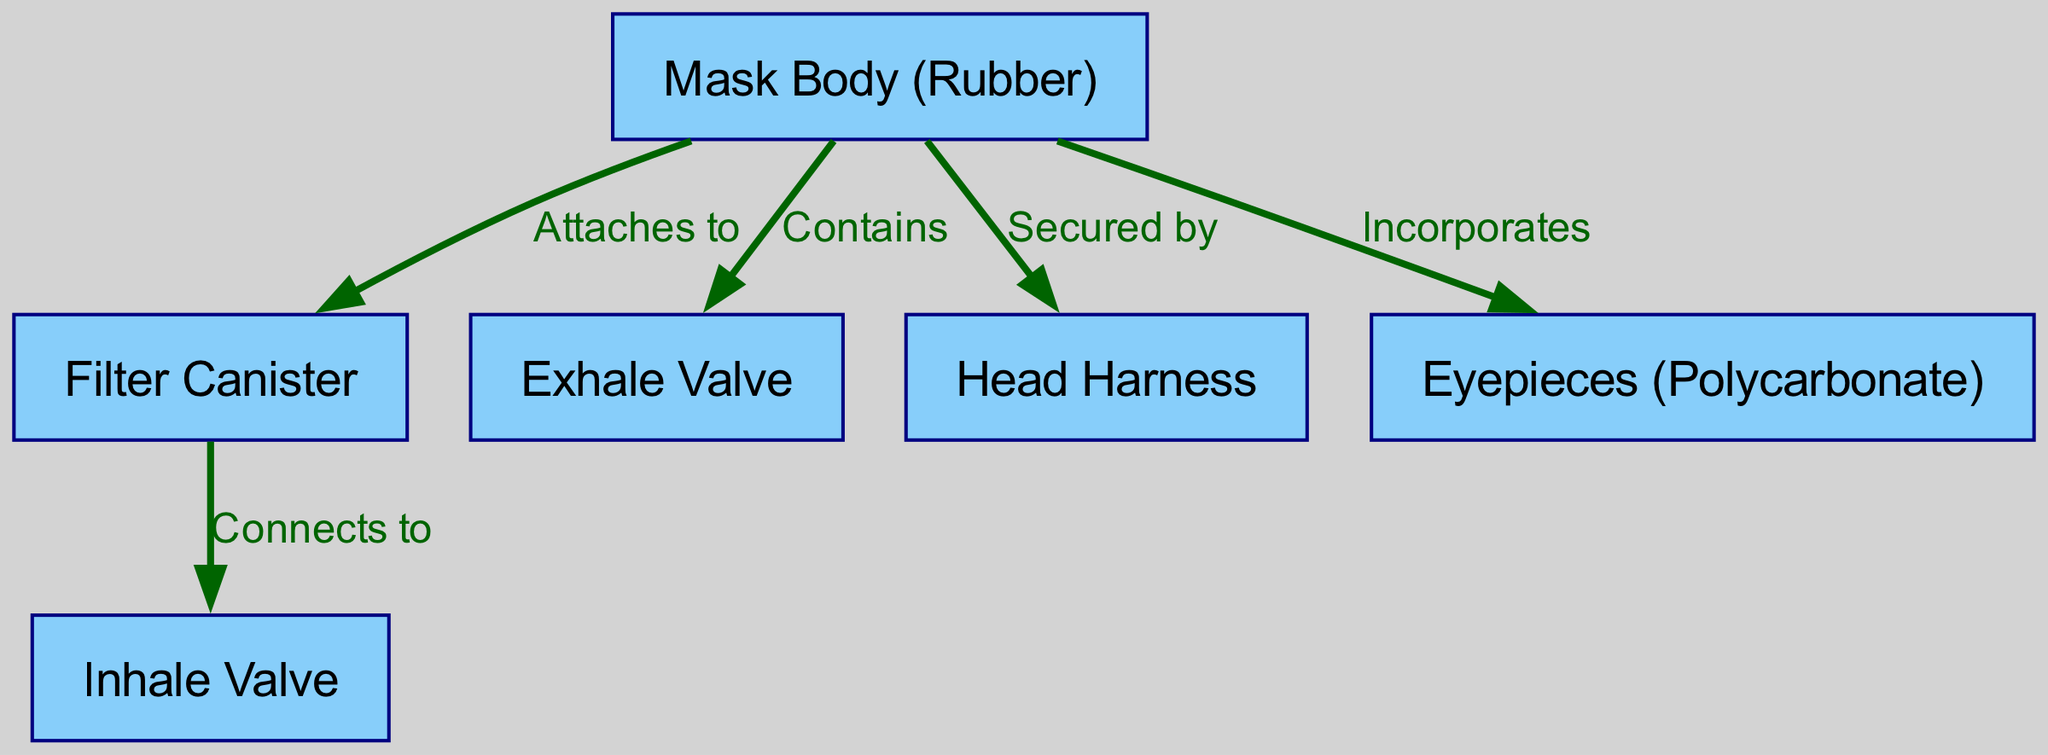What is the material of the mask body? The label in the diagram indicates that the mask body is made of rubber.
Answer: Rubber How many main components are depicted in the diagram? The diagram illustrates six components, which are the mask body, filter canister, exhale valve, inhale valve, head harness, and eyepieces.
Answer: Six What component is connected to the inhalation valve? The diagram shows that the filter canister connects to the inhale valve.
Answer: Filter Canister Which component secures the gas mask to the head? According to the diagram, the head harness is responsible for securing the gas mask.
Answer: Head Harness What is the purpose of the exhale valve? The exhale valve is contained within the mask body, allowing exhaled air to escape, but the specific purpose is not stated in the diagram.
Answer: Allows exhaled air to escape What does the filter canister connect to? The filter canister connects directly to the inhale valve as indicated in the diagram.
Answer: Inhale Valve What is incorporated into the mask body for vision? The eyepieces, which are made of polycarbonate, are incorporated into the mask body to provide vision.
Answer: Eyepieces What is the relationship between the mask body and the filter canister? The diagram shows that the filter canister attaches to the mask body, indicating a direct connection for filtration purposes.
Answer: Attaches to How many edges are present in the diagram? The diagram has five edges representing the connections between the components, which are illustrated by the arrows.
Answer: Five What material are the eyepieces made from? The diagram specifies that the eyepieces are made from polycarbonate, as labeled.
Answer: Polycarbonate 